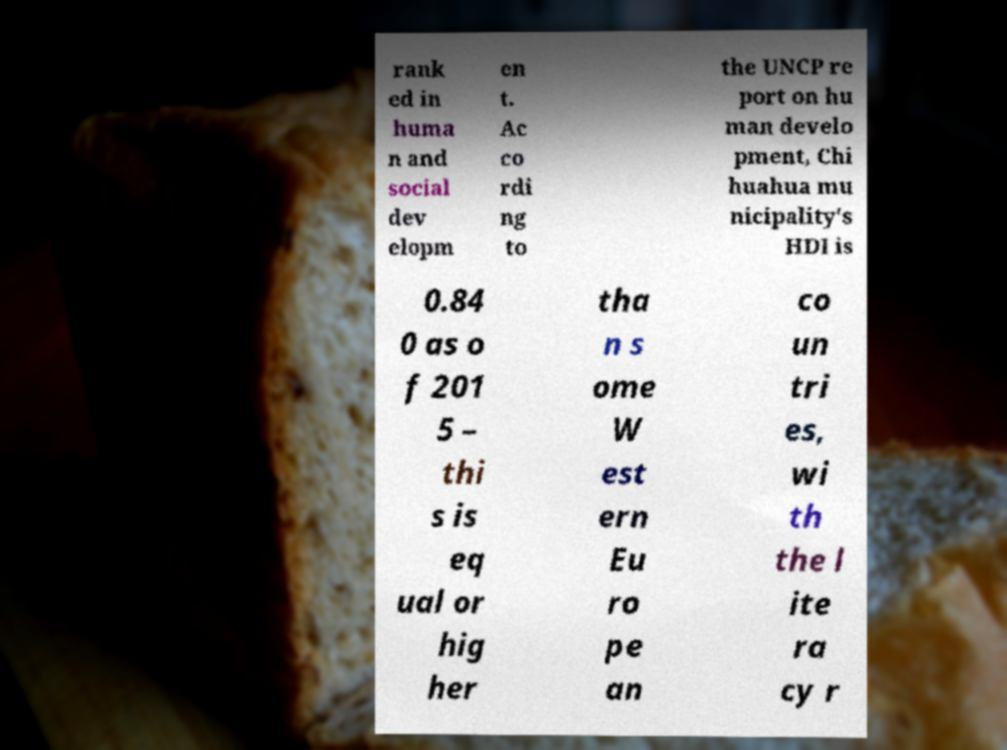Could you extract and type out the text from this image? rank ed in huma n and social dev elopm en t. Ac co rdi ng to the UNCP re port on hu man develo pment, Chi huahua mu nicipality's HDI is 0.84 0 as o f 201 5 – thi s is eq ual or hig her tha n s ome W est ern Eu ro pe an co un tri es, wi th the l ite ra cy r 